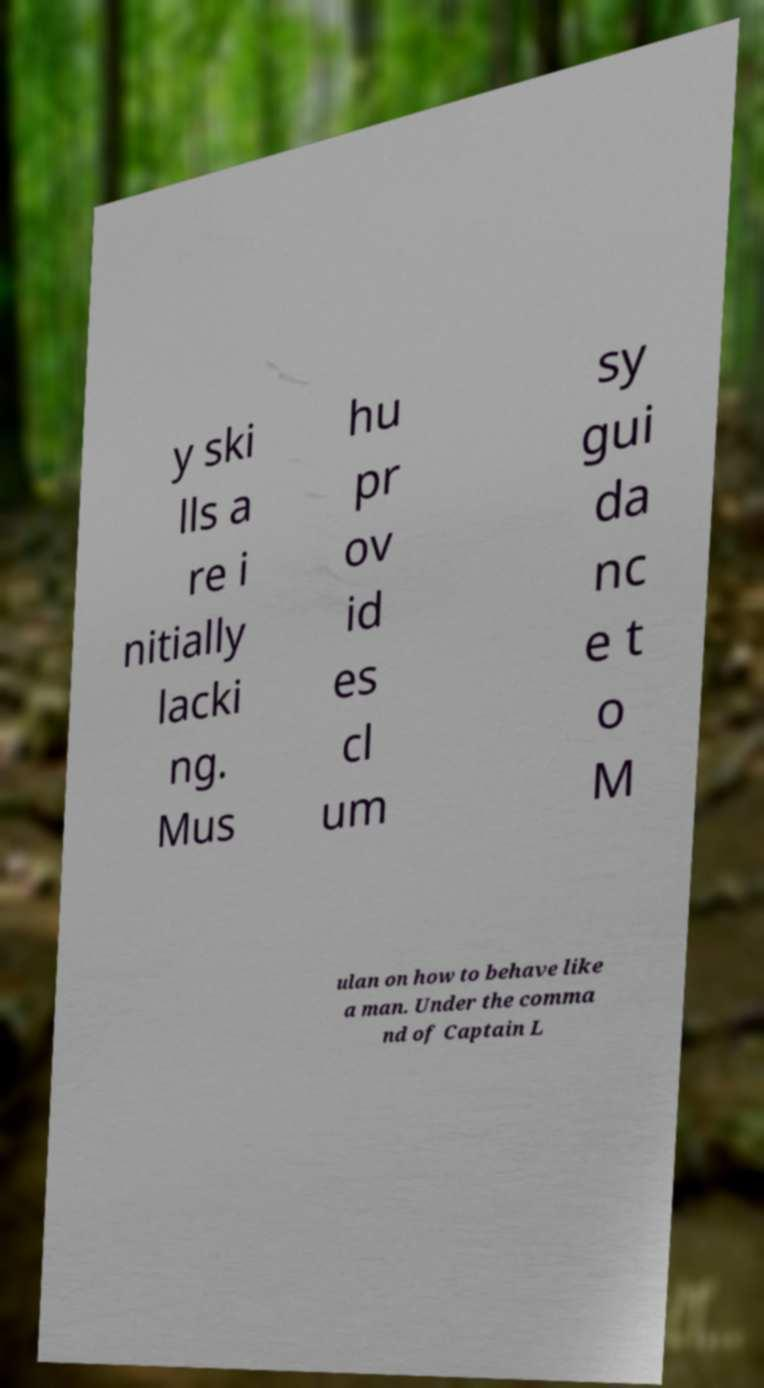Can you accurately transcribe the text from the provided image for me? y ski lls a re i nitially lacki ng. Mus hu pr ov id es cl um sy gui da nc e t o M ulan on how to behave like a man. Under the comma nd of Captain L 